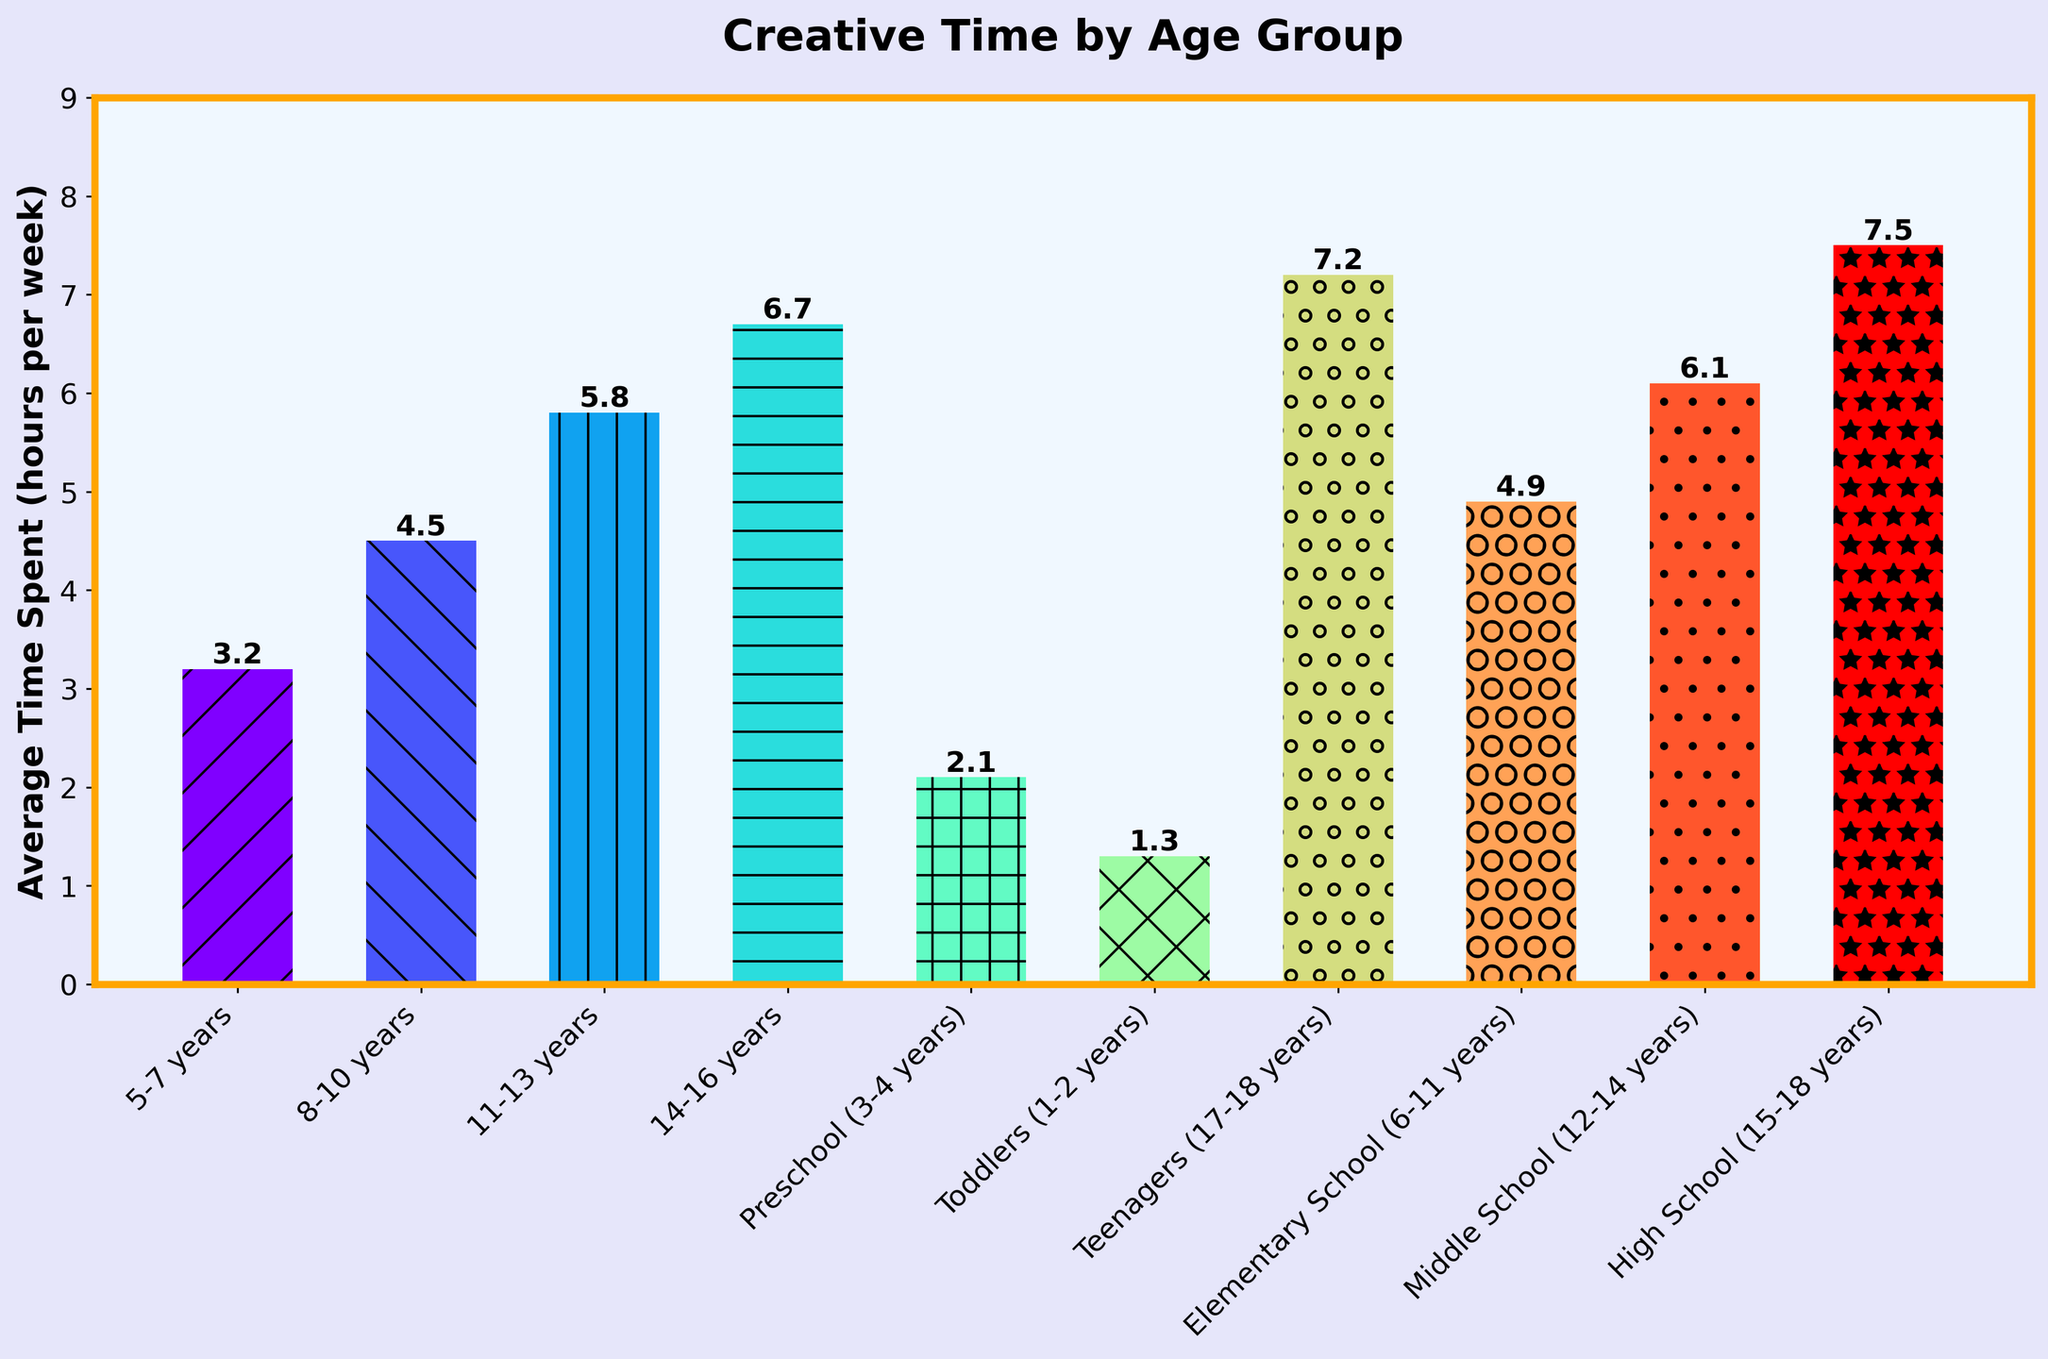Which age group spends the least amount of time on creative activities? Look at the height of the bars on the chart. The lowest one represents the age group "Toddlers (1-2 years)" who spend 1.3 hours per week.
Answer: Toddlers (1-2 years) Which age group spends the most time on creative activities? Look at the height of the bars on the chart. The highest one represents the age group "High School (15-18 years)" who spend 7.5 hours per week.
Answer: High School (15-18 years) How much more creative time do Teenagers (17-18 years) spend compared to Preschool (3-4 years)? Teenagers spend 7.2 hours per week, and Preschoolers spend 2.1 hours per week. Subtract 2.1 from 7.2.
Answer: 5.1 What is the combined average time spent on creative activities by Elementary School (6-11 years) and Middle School (12-14 years) students? Elementary School students spend 4.9 hours and Middle School students spend 6.1 hours. Add 4.9 and 6.1.
Answer: 11.0 Which age groups spend more than 5 hours per week on creative activities? Look for bars taller than 5 units. The age groups are 11-13 years (5.8 hours), 14-16 years (6.7 hours), Teenagers (17-18 years) (7.2 hours), Middle School (12-14 years) (6.1 hours), and High School (15-18 years) (7.5 hours).
Answer: 11-13 years, 14-16 years, 17-18 years, 12-14 years, 15-18 years How much time do kids aged 8-10 years spend compared to those aged 5-7 years? Kids aged 8-10 years spend 4.5 hours per week and those aged 5-7 years spend 3.2 hours. Subtract 3.2 from 4.5.
Answer: 1.3 What's the difference in creative time between the oldest and youngest age groups? The oldest group (High School 15-18 years) spends 7.5 hours, and the youngest group (Toddlers 1-2 years) spends 1.3 hours. Subtract 1.3 from 7.5.
Answer: 6.2 What is the average time spent on creative activities by age groups from Preschool (3-4 years) to 14-16 years? The average for Preschool (2.1), 5-7 years (3.2), 8-10 years (4.5), 11-13 years (5.8), and 14-16 years (6.7). Add these times and divide by the number of groups, which is 5. (2.1 + 3.2 + 4.5 + 5.8 + 6.7) / 5 = 4.46
Answer: 4.46 